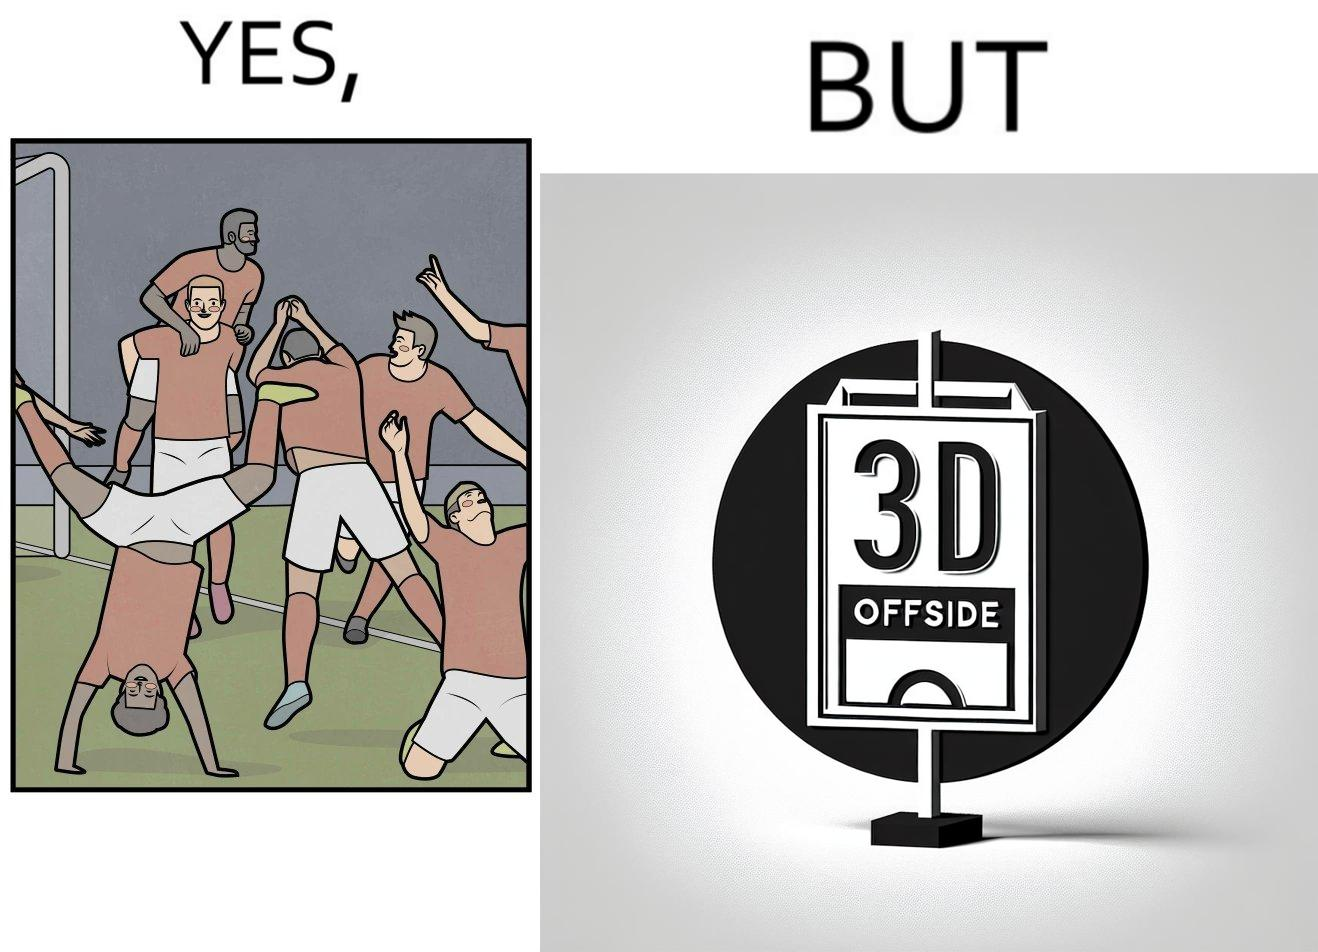Is this image satirical or non-satirical? Yes, this image is satirical. 